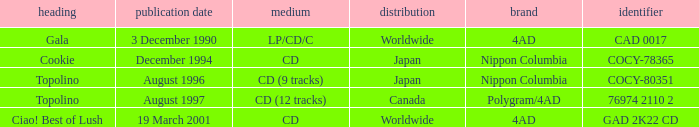When was Gala released? Worldwide. 